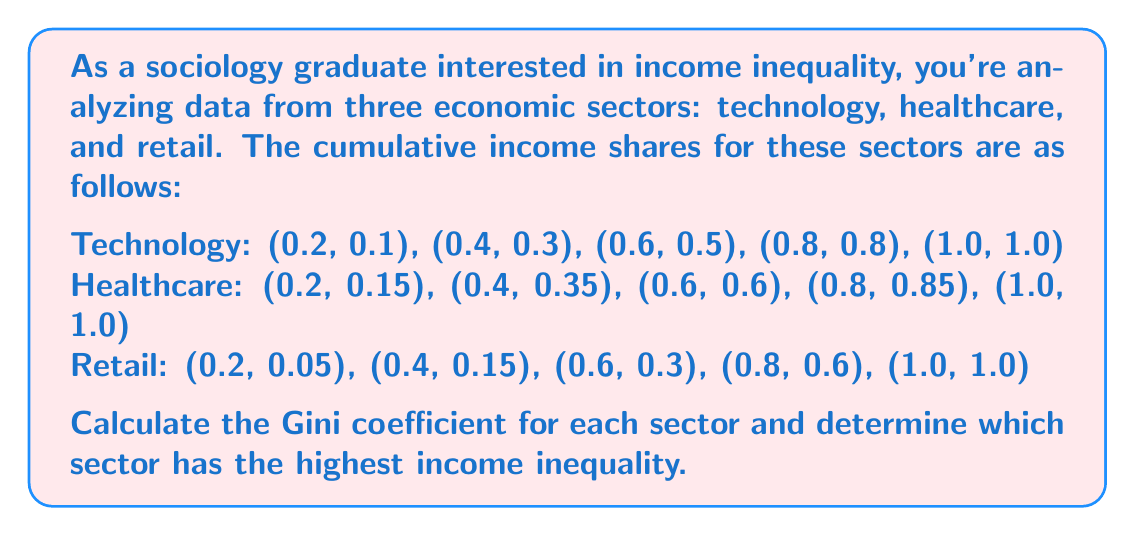Can you answer this question? To calculate the Gini coefficient for each sector, we'll use the formula:

$$ G = 1 - \sum_{i=1}^{n} (X_i - X_{i-1})(Y_i + Y_{i-1}) $$

Where $X_i$ is the cumulative proportion of the population, and $Y_i$ is the cumulative proportion of income.

For each sector:

1. Technology:
$$ G_{tech} = 1 - [(0.2-0)(0.1+0) + (0.4-0.2)(0.3+0.1) + (0.6-0.4)(0.5+0.3) + (0.8-0.6)(0.8+0.5) + (1-0.8)(1+0.8)] $$
$$ G_{tech} = 1 - [0.02 + 0.08 + 0.16 + 0.26 + 0.36] = 1 - 0.88 = 0.12 $$

2. Healthcare:
$$ G_{health} = 1 - [(0.2-0)(0.15+0) + (0.4-0.2)(0.35+0.15) + (0.6-0.4)(0.6+0.35) + (0.8-0.6)(0.85+0.6) + (1-0.8)(1+0.85)] $$
$$ G_{health} = 1 - [0.03 + 0.1 + 0.19 + 0.29 + 0.37] = 1 - 0.98 = 0.02 $$

3. Retail:
$$ G_{retail} = 1 - [(0.2-0)(0.05+0) + (0.4-0.2)(0.15+0.05) + (0.6-0.4)(0.3+0.15) + (0.8-0.6)(0.6+0.3) + (1-0.8)(1+0.6)] $$
$$ G_{retail} = 1 - [0.01 + 0.04 + 0.09 + 0.18 + 0.32] = 1 - 0.64 = 0.36 $$

The Gini coefficient ranges from 0 (perfect equality) to 1 (perfect inequality). A higher Gini coefficient indicates greater inequality.
Answer: The Gini coefficients for each sector are:
Technology: 0.12
Healthcare: 0.02
Retail: 0.36

The retail sector has the highest income inequality with a Gini coefficient of 0.36. 